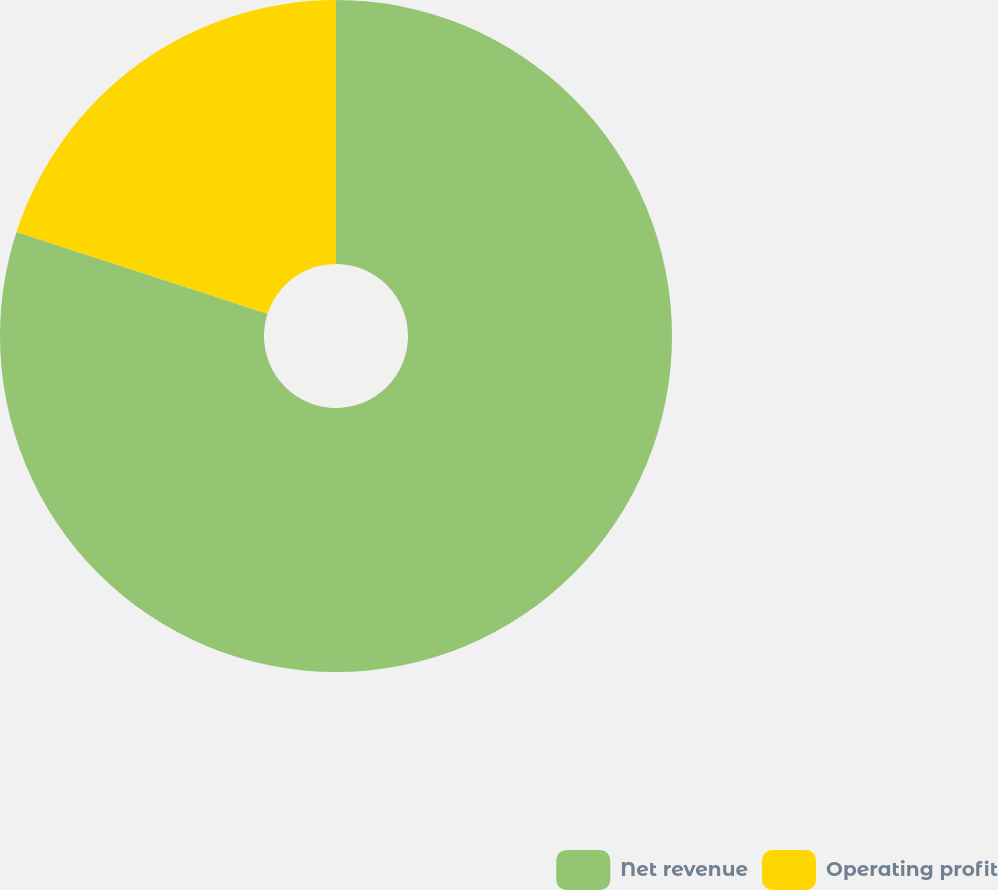Convert chart. <chart><loc_0><loc_0><loc_500><loc_500><pie_chart><fcel>Net revenue<fcel>Operating profit<nl><fcel>80.01%<fcel>19.99%<nl></chart> 